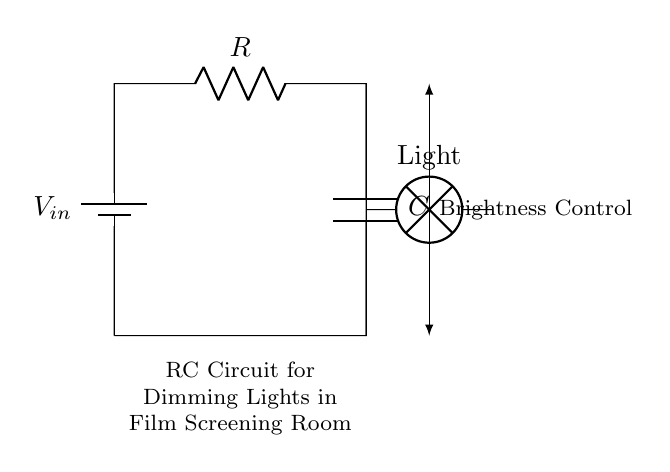What type of circuit is depicted? The circuit is identified as an RC circuit, which consists of a resistor and a capacitor. This is seen by observing the components labeled R and C that are connected in series with a battery.
Answer: RC circuit What component controls the brightness of the light? The brightness of the light is controlled by the resistor in the circuit. By adjusting the resistance, the current flowing to the lamp can be altered, affecting its brightness.
Answer: Resistor Which component stores energy? The capacitor is responsible for storing energy in the circuit. It charges and releases energy to the load (lamp) as needed, which is characteristic of capacitors in RC circuits.
Answer: Capacitor What is the function of the lamp in this circuit? The lamp functions as the load, converting electrical energy into light. It shows the visual effect of the controlled current flowing through it due to the resistor and capacitor arrangement.
Answer: Light How does increasing the resistance affect the brightness? Increasing the resistance will decrease the current flowing to the lamp, which will reduce its brightness. This relationship is due to Ohm's Law, where current is inversely related to resistance in a series circuit.
Answer: Decreases brightness What is the role of the capacitor in dimming the lights? The capacitor smooths out the fluctuations in current and provides a delayed response, creating a dimming effect. This characteristic is essential in allowing gradual changes in brightness rather than abrupt ones.
Answer: Smoothing current What is the configuration of the capacitor and resistor in the circuit? Both the capacitor and the resistor are configured in series with the light bulb, forming a complete circuit from the voltage source to the load. This configuration is typical for RC circuits used in dimming applications.
Answer: Series configuration 